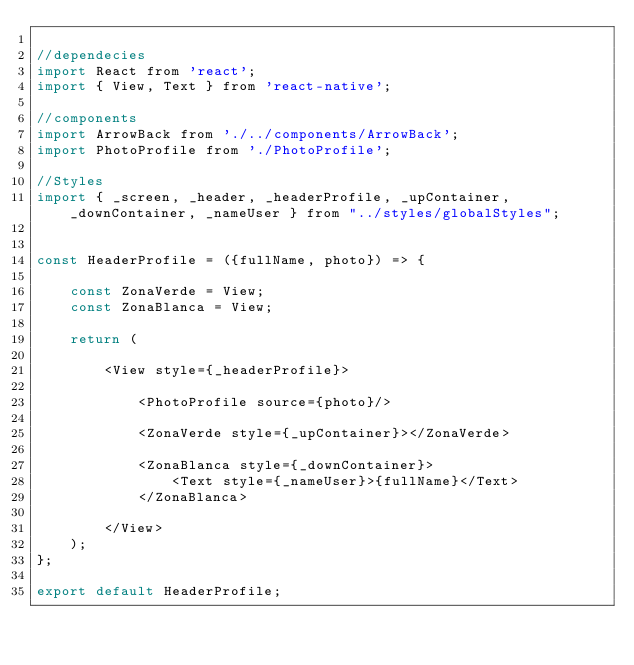Convert code to text. <code><loc_0><loc_0><loc_500><loc_500><_JavaScript_>
//dependecies
import React from 'react';
import { View, Text } from 'react-native';

//components
import ArrowBack from './../components/ArrowBack';
import PhotoProfile from './PhotoProfile';

//Styles
import { _screen, _header, _headerProfile, _upContainer, _downContainer, _nameUser } from "../styles/globalStyles";


const HeaderProfile = ({fullName, photo}) => {

    const ZonaVerde = View;
    const ZonaBlanca = View;
    
    return (

        <View style={_headerProfile}>

            <PhotoProfile source={photo}/>

            <ZonaVerde style={_upContainer}></ZonaVerde>

            <ZonaBlanca style={_downContainer}>
                <Text style={_nameUser}>{fullName}</Text>
            </ZonaBlanca>

        </View>
    );
};

export default HeaderProfile;</code> 